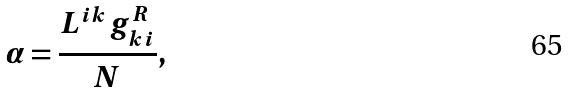Convert formula to latex. <formula><loc_0><loc_0><loc_500><loc_500>\alpha = \frac { L ^ { i k } g _ { k i } ^ { R } } { N } ,</formula> 